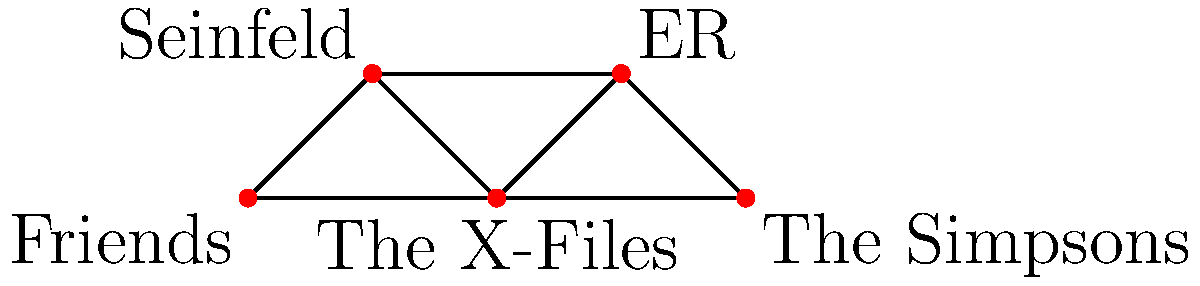In the graph above, each vertex represents a popular '90s TV show, and edges represent crossover episodes between shows. What is the minimum number of edges that need to be removed to disconnect "Friends" from "The Simpsons"? To solve this problem, we need to find the minimum cut between "Friends" and "The Simpsons". Let's follow these steps:

1. Identify all possible paths from "Friends" to "The Simpsons":
   a. Friends -> The X-Files -> The Simpsons
   b. Friends -> Seinfeld -> ER -> The Simpsons

2. Observe that there are two distinct paths, and they don't share any common edges.

3. To disconnect "Friends" from "The Simpsons", we need to remove at least one edge from each path.

4. The minimum number of edges to remove would be 2, as removing any single edge would still leave one path intact.

5. For example, we could remove:
   - The edge between Friends and The X-Files
   - The edge between ER and The Simpsons

This would effectively disconnect "Friends" from "The Simpsons" with the minimum number of edge removals.
Answer: 2 